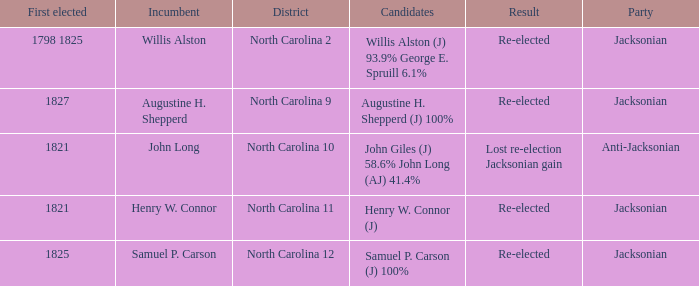Name the result for willis alston Re-elected. 